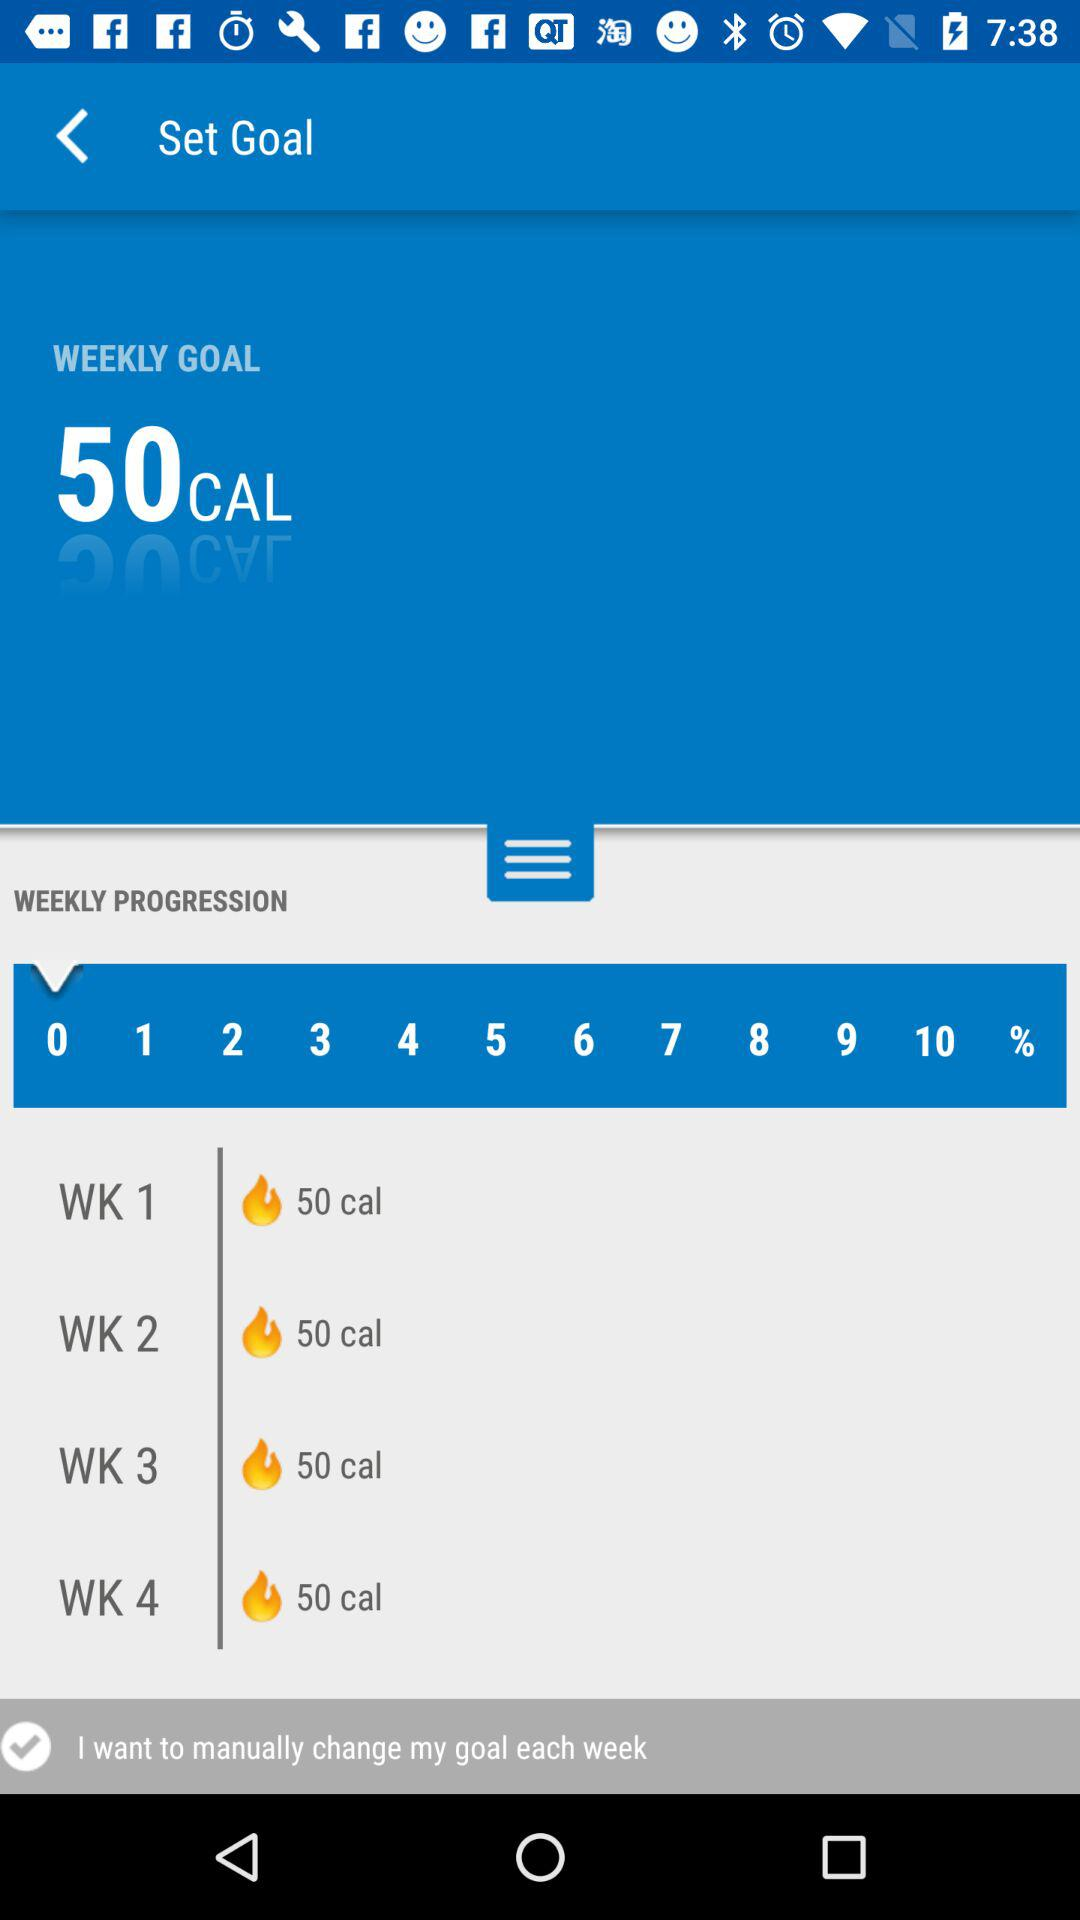What is the goal for week 3? The goal for week 3 is to burn 50 calories. 